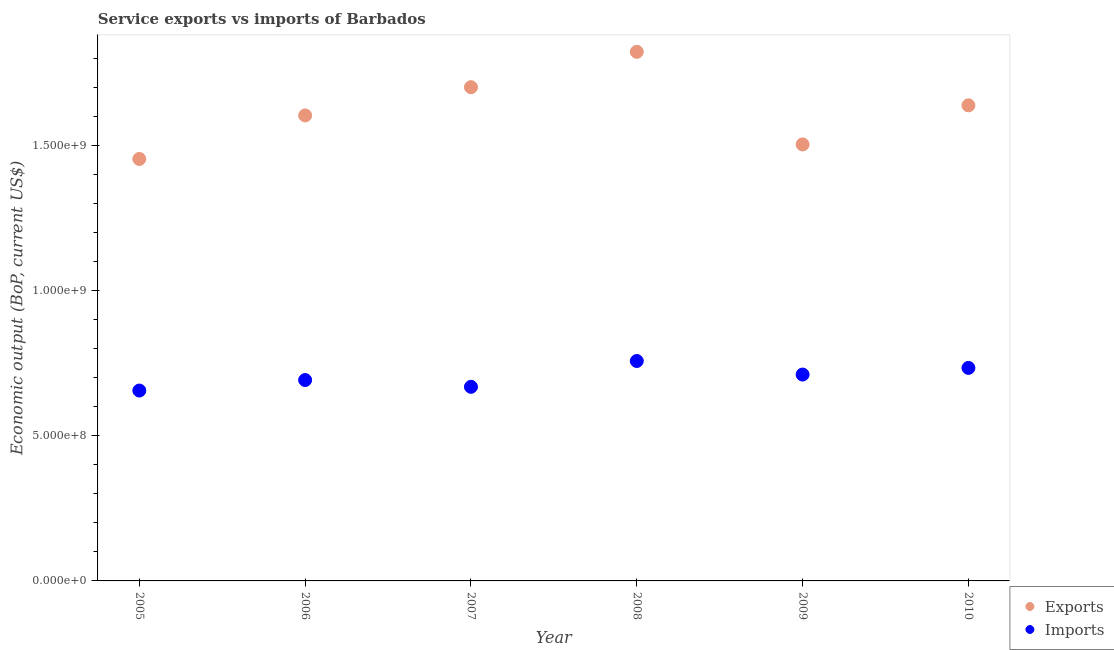How many different coloured dotlines are there?
Your answer should be very brief. 2. What is the amount of service exports in 2006?
Keep it short and to the point. 1.60e+09. Across all years, what is the maximum amount of service exports?
Make the answer very short. 1.82e+09. Across all years, what is the minimum amount of service exports?
Make the answer very short. 1.45e+09. In which year was the amount of service imports minimum?
Provide a short and direct response. 2005. What is the total amount of service exports in the graph?
Make the answer very short. 9.72e+09. What is the difference between the amount of service exports in 2008 and that in 2009?
Offer a terse response. 3.19e+08. What is the difference between the amount of service exports in 2006 and the amount of service imports in 2009?
Your answer should be very brief. 8.93e+08. What is the average amount of service exports per year?
Make the answer very short. 1.62e+09. In the year 2005, what is the difference between the amount of service imports and amount of service exports?
Make the answer very short. -7.98e+08. In how many years, is the amount of service imports greater than 400000000 US$?
Make the answer very short. 6. What is the ratio of the amount of service imports in 2009 to that in 2010?
Give a very brief answer. 0.97. Is the amount of service exports in 2007 less than that in 2009?
Offer a terse response. No. Is the difference between the amount of service exports in 2007 and 2010 greater than the difference between the amount of service imports in 2007 and 2010?
Your answer should be compact. Yes. What is the difference between the highest and the second highest amount of service imports?
Ensure brevity in your answer.  2.38e+07. What is the difference between the highest and the lowest amount of service exports?
Your response must be concise. 3.69e+08. Is the amount of service exports strictly greater than the amount of service imports over the years?
Offer a terse response. Yes. How many dotlines are there?
Keep it short and to the point. 2. How many years are there in the graph?
Ensure brevity in your answer.  6. What is the difference between two consecutive major ticks on the Y-axis?
Provide a succinct answer. 5.00e+08. Does the graph contain grids?
Give a very brief answer. No. How many legend labels are there?
Your response must be concise. 2. How are the legend labels stacked?
Offer a terse response. Vertical. What is the title of the graph?
Keep it short and to the point. Service exports vs imports of Barbados. What is the label or title of the Y-axis?
Offer a very short reply. Economic output (BoP, current US$). What is the Economic output (BoP, current US$) in Exports in 2005?
Your answer should be very brief. 1.45e+09. What is the Economic output (BoP, current US$) of Imports in 2005?
Ensure brevity in your answer.  6.56e+08. What is the Economic output (BoP, current US$) in Exports in 2006?
Offer a very short reply. 1.60e+09. What is the Economic output (BoP, current US$) in Imports in 2006?
Give a very brief answer. 6.92e+08. What is the Economic output (BoP, current US$) in Exports in 2007?
Offer a very short reply. 1.70e+09. What is the Economic output (BoP, current US$) in Imports in 2007?
Provide a succinct answer. 6.69e+08. What is the Economic output (BoP, current US$) of Exports in 2008?
Provide a short and direct response. 1.82e+09. What is the Economic output (BoP, current US$) of Imports in 2008?
Give a very brief answer. 7.58e+08. What is the Economic output (BoP, current US$) of Exports in 2009?
Ensure brevity in your answer.  1.50e+09. What is the Economic output (BoP, current US$) in Imports in 2009?
Provide a succinct answer. 7.11e+08. What is the Economic output (BoP, current US$) in Exports in 2010?
Make the answer very short. 1.64e+09. What is the Economic output (BoP, current US$) of Imports in 2010?
Provide a succinct answer. 7.34e+08. Across all years, what is the maximum Economic output (BoP, current US$) of Exports?
Your answer should be compact. 1.82e+09. Across all years, what is the maximum Economic output (BoP, current US$) of Imports?
Give a very brief answer. 7.58e+08. Across all years, what is the minimum Economic output (BoP, current US$) in Exports?
Provide a short and direct response. 1.45e+09. Across all years, what is the minimum Economic output (BoP, current US$) of Imports?
Your answer should be very brief. 6.56e+08. What is the total Economic output (BoP, current US$) in Exports in the graph?
Your answer should be compact. 9.72e+09. What is the total Economic output (BoP, current US$) of Imports in the graph?
Give a very brief answer. 4.22e+09. What is the difference between the Economic output (BoP, current US$) in Exports in 2005 and that in 2006?
Your response must be concise. -1.50e+08. What is the difference between the Economic output (BoP, current US$) of Imports in 2005 and that in 2006?
Ensure brevity in your answer.  -3.62e+07. What is the difference between the Economic output (BoP, current US$) of Exports in 2005 and that in 2007?
Make the answer very short. -2.47e+08. What is the difference between the Economic output (BoP, current US$) in Imports in 2005 and that in 2007?
Make the answer very short. -1.29e+07. What is the difference between the Economic output (BoP, current US$) in Exports in 2005 and that in 2008?
Your response must be concise. -3.69e+08. What is the difference between the Economic output (BoP, current US$) of Imports in 2005 and that in 2008?
Make the answer very short. -1.02e+08. What is the difference between the Economic output (BoP, current US$) of Exports in 2005 and that in 2009?
Your response must be concise. -5.01e+07. What is the difference between the Economic output (BoP, current US$) of Imports in 2005 and that in 2009?
Give a very brief answer. -5.51e+07. What is the difference between the Economic output (BoP, current US$) in Exports in 2005 and that in 2010?
Offer a terse response. -1.85e+08. What is the difference between the Economic output (BoP, current US$) of Imports in 2005 and that in 2010?
Offer a very short reply. -7.80e+07. What is the difference between the Economic output (BoP, current US$) of Exports in 2006 and that in 2007?
Provide a succinct answer. -9.73e+07. What is the difference between the Economic output (BoP, current US$) in Imports in 2006 and that in 2007?
Offer a very short reply. 2.33e+07. What is the difference between the Economic output (BoP, current US$) of Exports in 2006 and that in 2008?
Your answer should be very brief. -2.19e+08. What is the difference between the Economic output (BoP, current US$) in Imports in 2006 and that in 2008?
Ensure brevity in your answer.  -6.56e+07. What is the difference between the Economic output (BoP, current US$) in Exports in 2006 and that in 2009?
Provide a succinct answer. 9.98e+07. What is the difference between the Economic output (BoP, current US$) of Imports in 2006 and that in 2009?
Ensure brevity in your answer.  -1.89e+07. What is the difference between the Economic output (BoP, current US$) of Exports in 2006 and that in 2010?
Keep it short and to the point. -3.48e+07. What is the difference between the Economic output (BoP, current US$) in Imports in 2006 and that in 2010?
Ensure brevity in your answer.  -4.18e+07. What is the difference between the Economic output (BoP, current US$) in Exports in 2007 and that in 2008?
Provide a short and direct response. -1.22e+08. What is the difference between the Economic output (BoP, current US$) of Imports in 2007 and that in 2008?
Keep it short and to the point. -8.89e+07. What is the difference between the Economic output (BoP, current US$) in Exports in 2007 and that in 2009?
Make the answer very short. 1.97e+08. What is the difference between the Economic output (BoP, current US$) of Imports in 2007 and that in 2009?
Ensure brevity in your answer.  -4.22e+07. What is the difference between the Economic output (BoP, current US$) of Exports in 2007 and that in 2010?
Offer a very short reply. 6.25e+07. What is the difference between the Economic output (BoP, current US$) of Imports in 2007 and that in 2010?
Offer a terse response. -6.51e+07. What is the difference between the Economic output (BoP, current US$) in Exports in 2008 and that in 2009?
Make the answer very short. 3.19e+08. What is the difference between the Economic output (BoP, current US$) of Imports in 2008 and that in 2009?
Your answer should be very brief. 4.66e+07. What is the difference between the Economic output (BoP, current US$) in Exports in 2008 and that in 2010?
Offer a terse response. 1.84e+08. What is the difference between the Economic output (BoP, current US$) in Imports in 2008 and that in 2010?
Offer a very short reply. 2.38e+07. What is the difference between the Economic output (BoP, current US$) of Exports in 2009 and that in 2010?
Your answer should be very brief. -1.35e+08. What is the difference between the Economic output (BoP, current US$) in Imports in 2009 and that in 2010?
Your answer should be compact. -2.29e+07. What is the difference between the Economic output (BoP, current US$) in Exports in 2005 and the Economic output (BoP, current US$) in Imports in 2006?
Your response must be concise. 7.62e+08. What is the difference between the Economic output (BoP, current US$) in Exports in 2005 and the Economic output (BoP, current US$) in Imports in 2007?
Provide a short and direct response. 7.85e+08. What is the difference between the Economic output (BoP, current US$) in Exports in 2005 and the Economic output (BoP, current US$) in Imports in 2008?
Your answer should be compact. 6.96e+08. What is the difference between the Economic output (BoP, current US$) of Exports in 2005 and the Economic output (BoP, current US$) of Imports in 2009?
Your answer should be compact. 7.43e+08. What is the difference between the Economic output (BoP, current US$) of Exports in 2005 and the Economic output (BoP, current US$) of Imports in 2010?
Your response must be concise. 7.20e+08. What is the difference between the Economic output (BoP, current US$) in Exports in 2006 and the Economic output (BoP, current US$) in Imports in 2007?
Your answer should be very brief. 9.35e+08. What is the difference between the Economic output (BoP, current US$) in Exports in 2006 and the Economic output (BoP, current US$) in Imports in 2008?
Ensure brevity in your answer.  8.46e+08. What is the difference between the Economic output (BoP, current US$) in Exports in 2006 and the Economic output (BoP, current US$) in Imports in 2009?
Offer a very short reply. 8.93e+08. What is the difference between the Economic output (BoP, current US$) of Exports in 2006 and the Economic output (BoP, current US$) of Imports in 2010?
Ensure brevity in your answer.  8.70e+08. What is the difference between the Economic output (BoP, current US$) of Exports in 2007 and the Economic output (BoP, current US$) of Imports in 2008?
Provide a succinct answer. 9.43e+08. What is the difference between the Economic output (BoP, current US$) in Exports in 2007 and the Economic output (BoP, current US$) in Imports in 2009?
Offer a very short reply. 9.90e+08. What is the difference between the Economic output (BoP, current US$) of Exports in 2007 and the Economic output (BoP, current US$) of Imports in 2010?
Your response must be concise. 9.67e+08. What is the difference between the Economic output (BoP, current US$) of Exports in 2008 and the Economic output (BoP, current US$) of Imports in 2009?
Offer a terse response. 1.11e+09. What is the difference between the Economic output (BoP, current US$) in Exports in 2008 and the Economic output (BoP, current US$) in Imports in 2010?
Your answer should be compact. 1.09e+09. What is the difference between the Economic output (BoP, current US$) in Exports in 2009 and the Economic output (BoP, current US$) in Imports in 2010?
Your response must be concise. 7.70e+08. What is the average Economic output (BoP, current US$) of Exports per year?
Offer a very short reply. 1.62e+09. What is the average Economic output (BoP, current US$) of Imports per year?
Give a very brief answer. 7.03e+08. In the year 2005, what is the difference between the Economic output (BoP, current US$) in Exports and Economic output (BoP, current US$) in Imports?
Offer a very short reply. 7.98e+08. In the year 2006, what is the difference between the Economic output (BoP, current US$) in Exports and Economic output (BoP, current US$) in Imports?
Provide a short and direct response. 9.11e+08. In the year 2007, what is the difference between the Economic output (BoP, current US$) of Exports and Economic output (BoP, current US$) of Imports?
Provide a short and direct response. 1.03e+09. In the year 2008, what is the difference between the Economic output (BoP, current US$) of Exports and Economic output (BoP, current US$) of Imports?
Keep it short and to the point. 1.07e+09. In the year 2009, what is the difference between the Economic output (BoP, current US$) in Exports and Economic output (BoP, current US$) in Imports?
Ensure brevity in your answer.  7.93e+08. In the year 2010, what is the difference between the Economic output (BoP, current US$) of Exports and Economic output (BoP, current US$) of Imports?
Offer a very short reply. 9.04e+08. What is the ratio of the Economic output (BoP, current US$) in Exports in 2005 to that in 2006?
Offer a very short reply. 0.91. What is the ratio of the Economic output (BoP, current US$) of Imports in 2005 to that in 2006?
Your answer should be compact. 0.95. What is the ratio of the Economic output (BoP, current US$) of Exports in 2005 to that in 2007?
Your answer should be very brief. 0.85. What is the ratio of the Economic output (BoP, current US$) in Imports in 2005 to that in 2007?
Your answer should be compact. 0.98. What is the ratio of the Economic output (BoP, current US$) of Exports in 2005 to that in 2008?
Your response must be concise. 0.8. What is the ratio of the Economic output (BoP, current US$) of Imports in 2005 to that in 2008?
Your answer should be very brief. 0.87. What is the ratio of the Economic output (BoP, current US$) of Exports in 2005 to that in 2009?
Make the answer very short. 0.97. What is the ratio of the Economic output (BoP, current US$) of Imports in 2005 to that in 2009?
Provide a succinct answer. 0.92. What is the ratio of the Economic output (BoP, current US$) in Exports in 2005 to that in 2010?
Offer a terse response. 0.89. What is the ratio of the Economic output (BoP, current US$) in Imports in 2005 to that in 2010?
Offer a very short reply. 0.89. What is the ratio of the Economic output (BoP, current US$) of Exports in 2006 to that in 2007?
Your answer should be compact. 0.94. What is the ratio of the Economic output (BoP, current US$) of Imports in 2006 to that in 2007?
Your response must be concise. 1.03. What is the ratio of the Economic output (BoP, current US$) of Exports in 2006 to that in 2008?
Give a very brief answer. 0.88. What is the ratio of the Economic output (BoP, current US$) in Imports in 2006 to that in 2008?
Your response must be concise. 0.91. What is the ratio of the Economic output (BoP, current US$) of Exports in 2006 to that in 2009?
Your response must be concise. 1.07. What is the ratio of the Economic output (BoP, current US$) of Imports in 2006 to that in 2009?
Make the answer very short. 0.97. What is the ratio of the Economic output (BoP, current US$) of Exports in 2006 to that in 2010?
Provide a succinct answer. 0.98. What is the ratio of the Economic output (BoP, current US$) of Imports in 2006 to that in 2010?
Provide a succinct answer. 0.94. What is the ratio of the Economic output (BoP, current US$) of Exports in 2007 to that in 2008?
Provide a succinct answer. 0.93. What is the ratio of the Economic output (BoP, current US$) of Imports in 2007 to that in 2008?
Make the answer very short. 0.88. What is the ratio of the Economic output (BoP, current US$) of Exports in 2007 to that in 2009?
Make the answer very short. 1.13. What is the ratio of the Economic output (BoP, current US$) in Imports in 2007 to that in 2009?
Provide a succinct answer. 0.94. What is the ratio of the Economic output (BoP, current US$) in Exports in 2007 to that in 2010?
Your response must be concise. 1.04. What is the ratio of the Economic output (BoP, current US$) in Imports in 2007 to that in 2010?
Your answer should be compact. 0.91. What is the ratio of the Economic output (BoP, current US$) in Exports in 2008 to that in 2009?
Offer a very short reply. 1.21. What is the ratio of the Economic output (BoP, current US$) in Imports in 2008 to that in 2009?
Your answer should be compact. 1.07. What is the ratio of the Economic output (BoP, current US$) of Exports in 2008 to that in 2010?
Keep it short and to the point. 1.11. What is the ratio of the Economic output (BoP, current US$) of Imports in 2008 to that in 2010?
Make the answer very short. 1.03. What is the ratio of the Economic output (BoP, current US$) in Exports in 2009 to that in 2010?
Ensure brevity in your answer.  0.92. What is the ratio of the Economic output (BoP, current US$) of Imports in 2009 to that in 2010?
Offer a terse response. 0.97. What is the difference between the highest and the second highest Economic output (BoP, current US$) in Exports?
Provide a short and direct response. 1.22e+08. What is the difference between the highest and the second highest Economic output (BoP, current US$) in Imports?
Keep it short and to the point. 2.38e+07. What is the difference between the highest and the lowest Economic output (BoP, current US$) of Exports?
Offer a terse response. 3.69e+08. What is the difference between the highest and the lowest Economic output (BoP, current US$) in Imports?
Your answer should be very brief. 1.02e+08. 